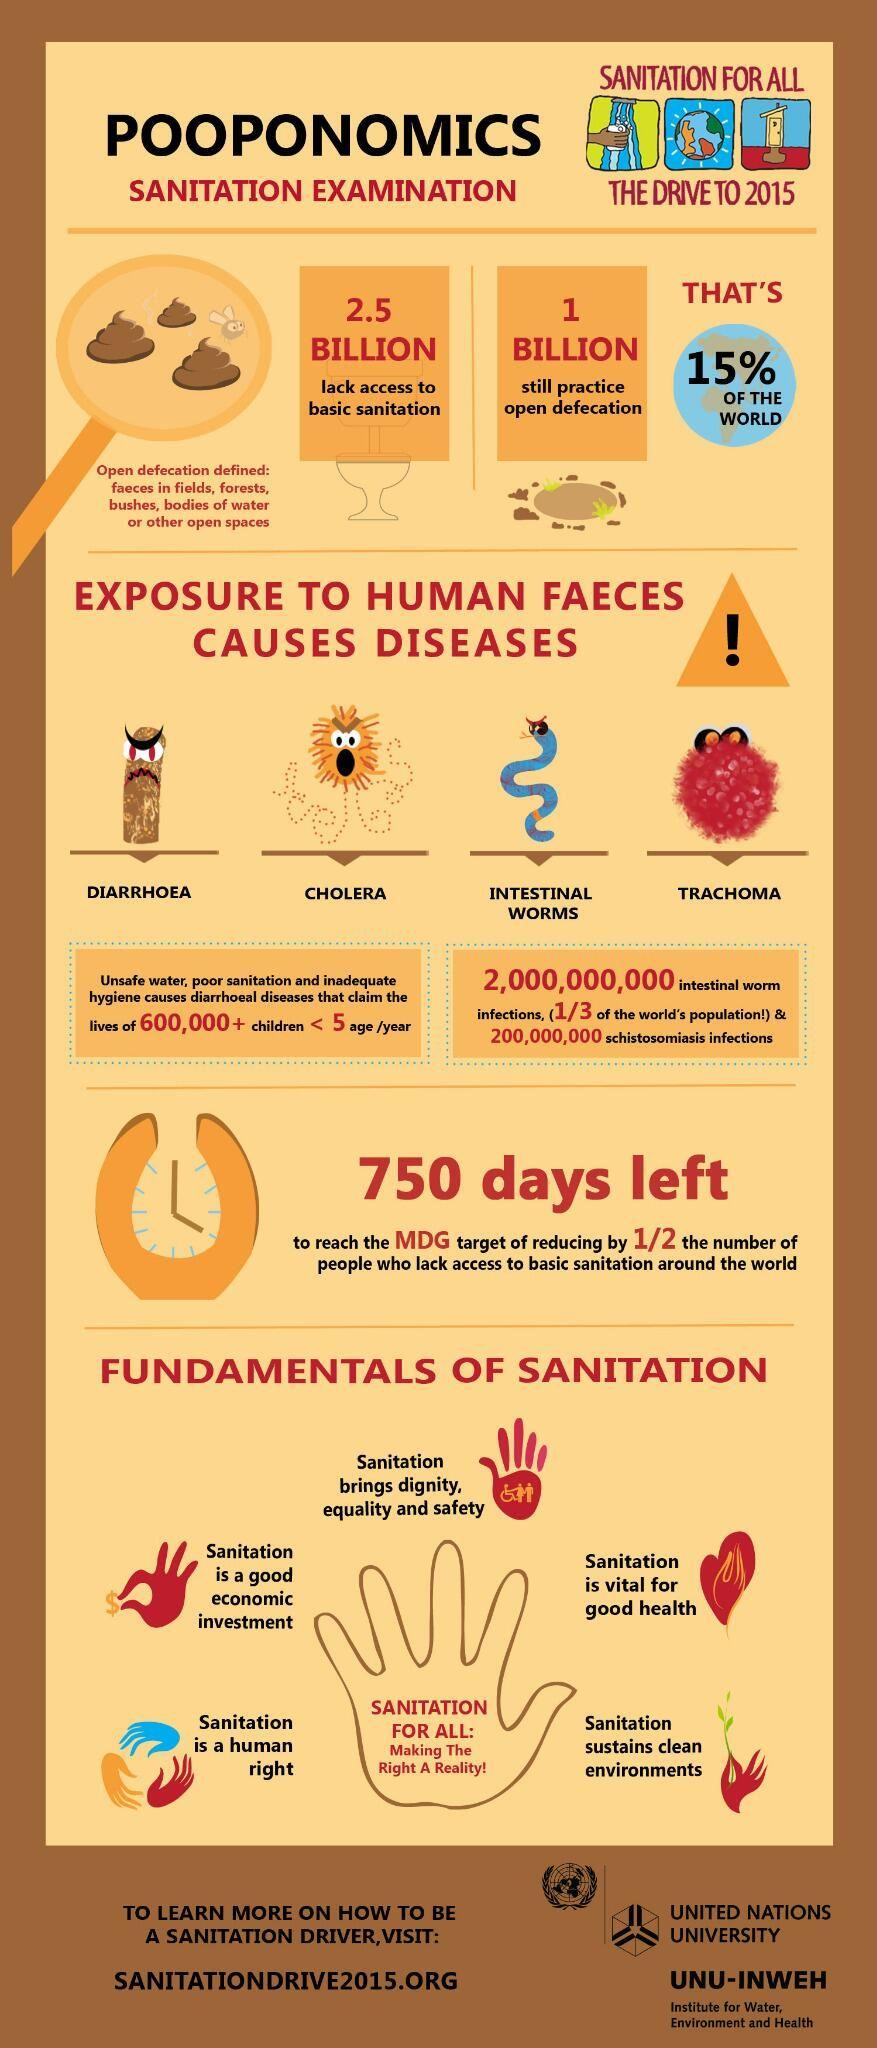Point out several critical features in this image. According to recent studies, approximately 15% of people globally still practice open defecation, indicating a significant portion of the population continues to lack access to adequate sanitation facilities. 